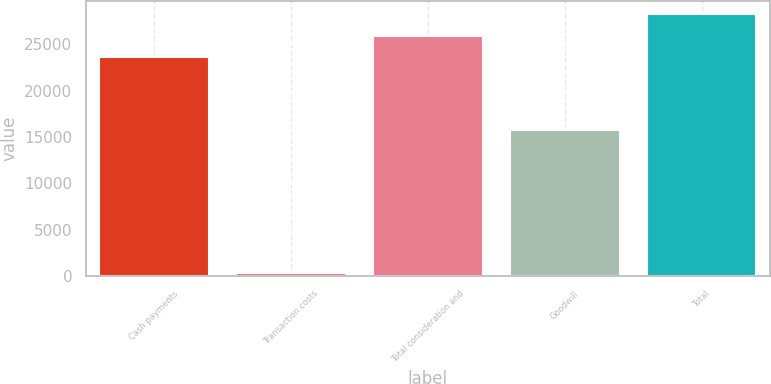<chart> <loc_0><loc_0><loc_500><loc_500><bar_chart><fcel>Cash payments<fcel>Transaction costs<fcel>Total consideration and<fcel>Goodwill<fcel>Total<nl><fcel>23573<fcel>375<fcel>25901.5<fcel>15738<fcel>28230<nl></chart> 